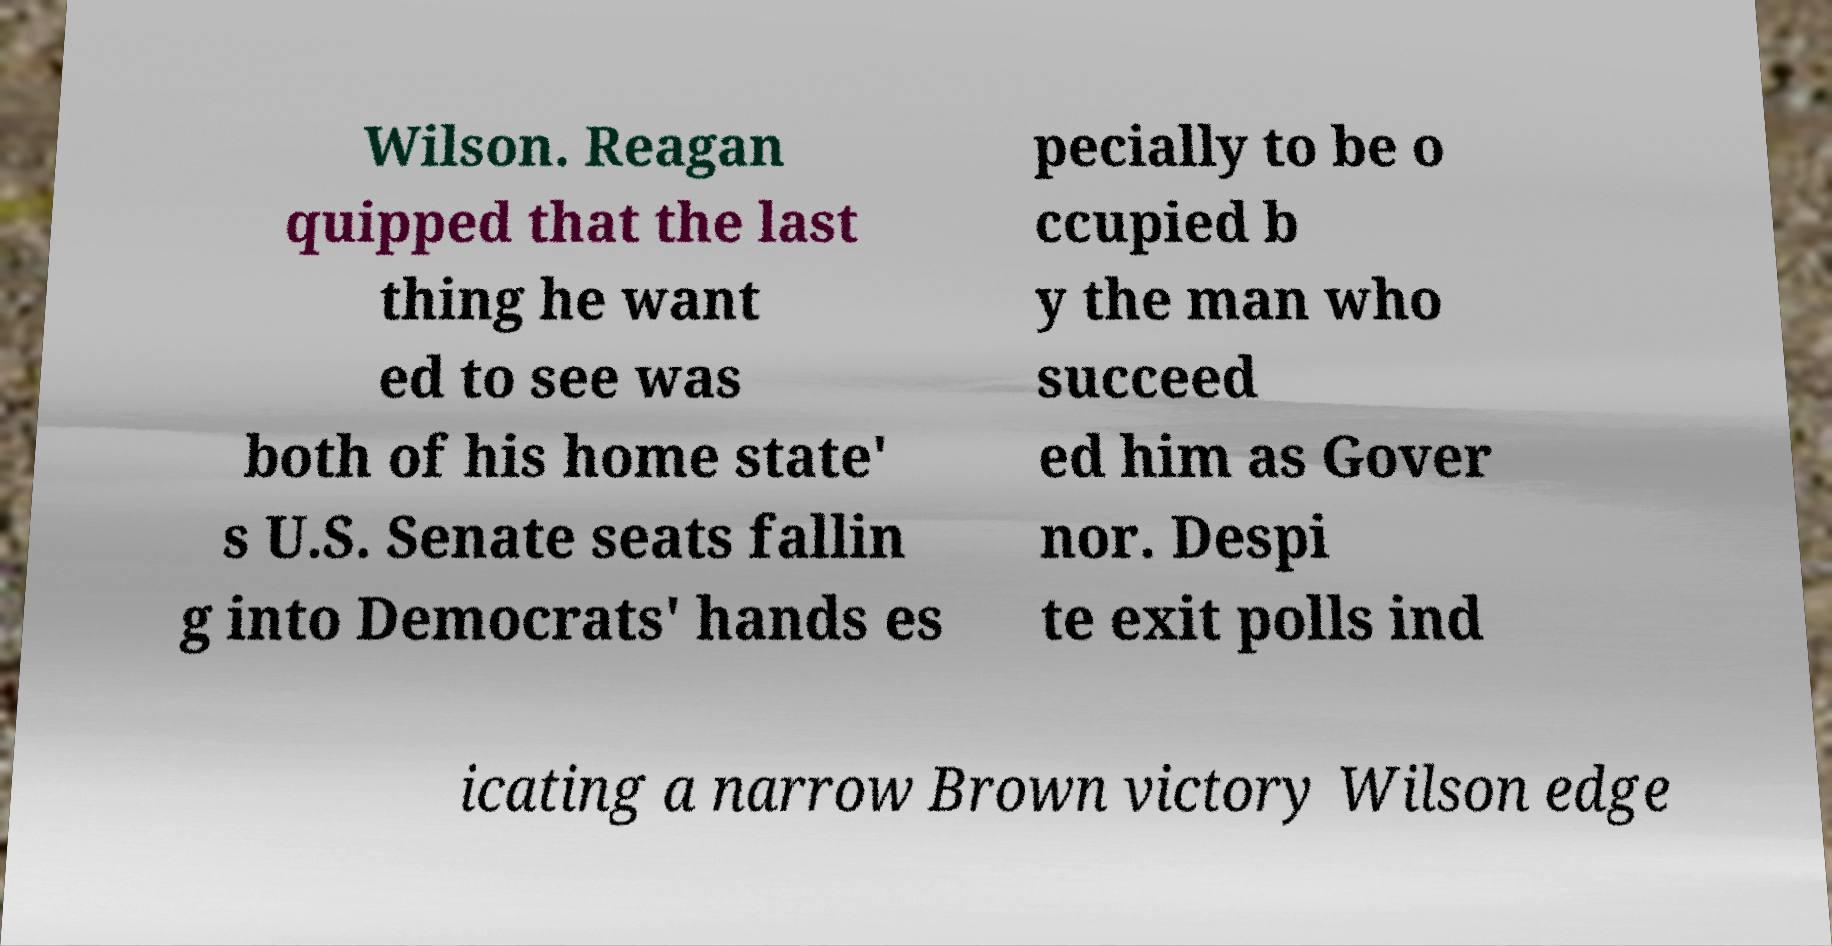Could you extract and type out the text from this image? Wilson. Reagan quipped that the last thing he want ed to see was both of his home state' s U.S. Senate seats fallin g into Democrats' hands es pecially to be o ccupied b y the man who succeed ed him as Gover nor. Despi te exit polls ind icating a narrow Brown victory Wilson edge 